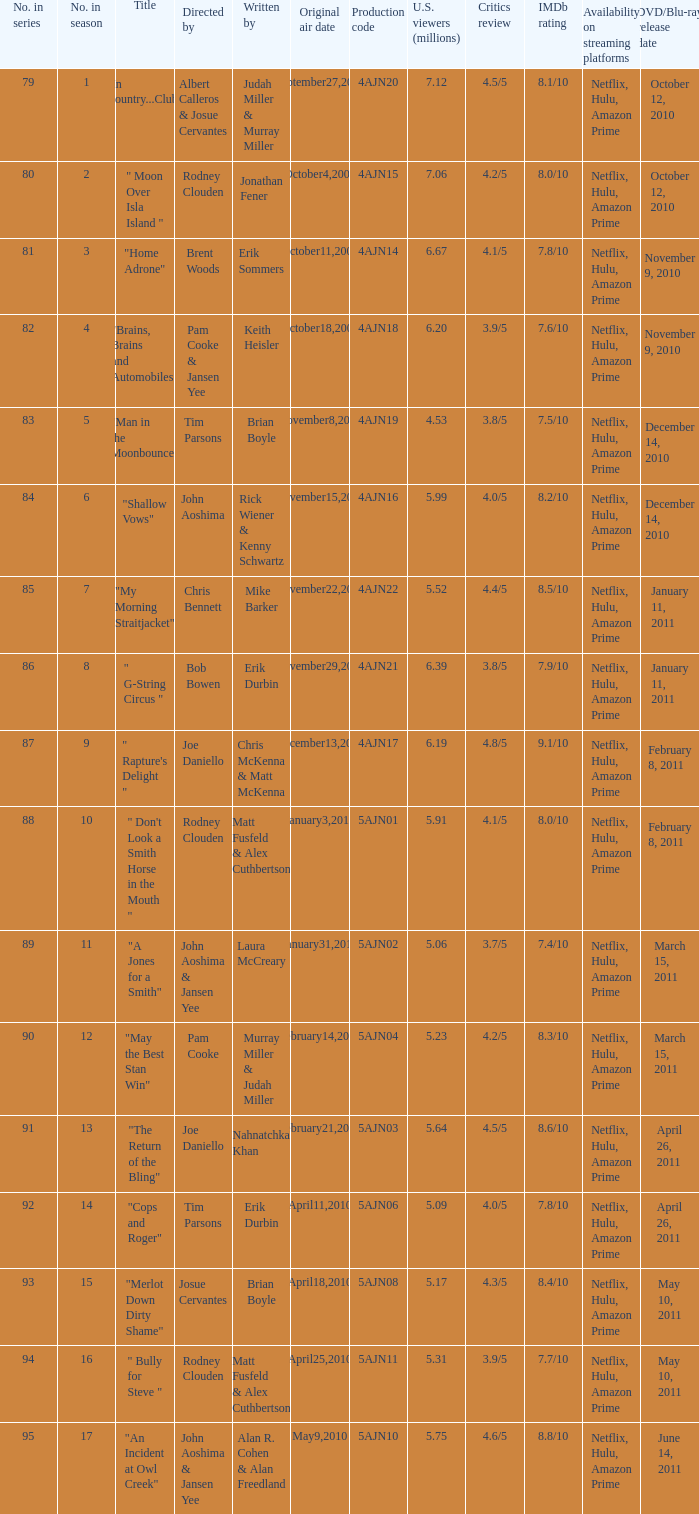Name who wrote 5ajn11 Matt Fusfeld & Alex Cuthbertson. 